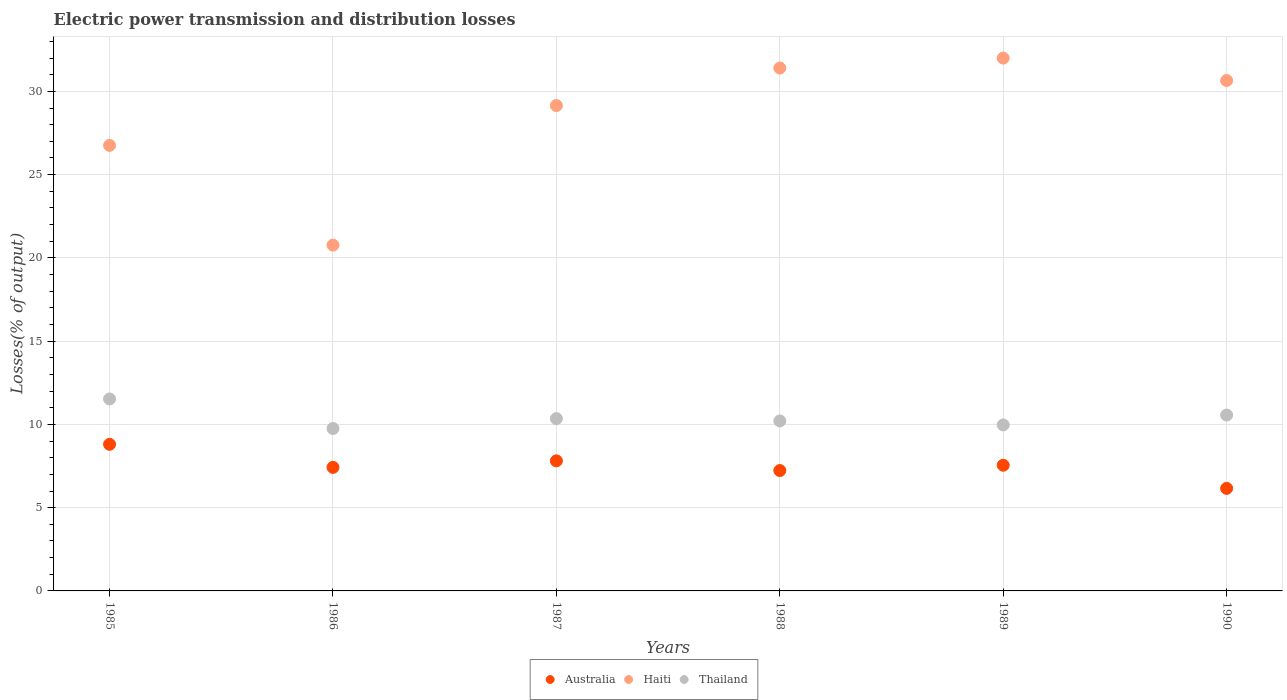How many different coloured dotlines are there?
Ensure brevity in your answer.  3. Is the number of dotlines equal to the number of legend labels?
Ensure brevity in your answer.  Yes. What is the electric power transmission and distribution losses in Thailand in 1988?
Provide a succinct answer. 10.21. Across all years, what is the maximum electric power transmission and distribution losses in Haiti?
Ensure brevity in your answer.  32. Across all years, what is the minimum electric power transmission and distribution losses in Thailand?
Your response must be concise. 9.75. In which year was the electric power transmission and distribution losses in Thailand maximum?
Your answer should be very brief. 1985. What is the total electric power transmission and distribution losses in Thailand in the graph?
Give a very brief answer. 62.37. What is the difference between the electric power transmission and distribution losses in Haiti in 1988 and that in 1990?
Your answer should be compact. 0.75. What is the difference between the electric power transmission and distribution losses in Haiti in 1986 and the electric power transmission and distribution losses in Australia in 1987?
Your answer should be very brief. 12.96. What is the average electric power transmission and distribution losses in Haiti per year?
Make the answer very short. 28.45. In the year 1986, what is the difference between the electric power transmission and distribution losses in Thailand and electric power transmission and distribution losses in Australia?
Offer a terse response. 2.33. In how many years, is the electric power transmission and distribution losses in Thailand greater than 9 %?
Ensure brevity in your answer.  6. What is the ratio of the electric power transmission and distribution losses in Thailand in 1987 to that in 1990?
Your response must be concise. 0.98. Is the electric power transmission and distribution losses in Australia in 1986 less than that in 1988?
Give a very brief answer. No. Is the difference between the electric power transmission and distribution losses in Thailand in 1986 and 1989 greater than the difference between the electric power transmission and distribution losses in Australia in 1986 and 1989?
Offer a terse response. No. What is the difference between the highest and the second highest electric power transmission and distribution losses in Australia?
Provide a succinct answer. 0.99. What is the difference between the highest and the lowest electric power transmission and distribution losses in Haiti?
Offer a terse response. 11.23. Are the values on the major ticks of Y-axis written in scientific E-notation?
Provide a short and direct response. No. Where does the legend appear in the graph?
Your response must be concise. Bottom center. What is the title of the graph?
Your response must be concise. Electric power transmission and distribution losses. What is the label or title of the Y-axis?
Ensure brevity in your answer.  Losses(% of output). What is the Losses(% of output) in Australia in 1985?
Offer a very short reply. 8.8. What is the Losses(% of output) in Haiti in 1985?
Provide a short and direct response. 26.76. What is the Losses(% of output) in Thailand in 1985?
Provide a succinct answer. 11.53. What is the Losses(% of output) in Australia in 1986?
Provide a succinct answer. 7.42. What is the Losses(% of output) of Haiti in 1986?
Offer a terse response. 20.77. What is the Losses(% of output) of Thailand in 1986?
Provide a short and direct response. 9.75. What is the Losses(% of output) of Australia in 1987?
Keep it short and to the point. 7.81. What is the Losses(% of output) in Haiti in 1987?
Provide a short and direct response. 29.15. What is the Losses(% of output) of Thailand in 1987?
Your answer should be compact. 10.35. What is the Losses(% of output) of Australia in 1988?
Make the answer very short. 7.23. What is the Losses(% of output) in Haiti in 1988?
Offer a very short reply. 31.4. What is the Losses(% of output) in Thailand in 1988?
Your answer should be compact. 10.21. What is the Losses(% of output) in Australia in 1989?
Make the answer very short. 7.55. What is the Losses(% of output) in Haiti in 1989?
Offer a very short reply. 32. What is the Losses(% of output) in Thailand in 1989?
Your response must be concise. 9.97. What is the Losses(% of output) in Australia in 1990?
Keep it short and to the point. 6.16. What is the Losses(% of output) in Haiti in 1990?
Provide a succinct answer. 30.65. What is the Losses(% of output) in Thailand in 1990?
Ensure brevity in your answer.  10.56. Across all years, what is the maximum Losses(% of output) in Australia?
Offer a very short reply. 8.8. Across all years, what is the maximum Losses(% of output) in Haiti?
Your response must be concise. 32. Across all years, what is the maximum Losses(% of output) in Thailand?
Provide a succinct answer. 11.53. Across all years, what is the minimum Losses(% of output) in Australia?
Offer a terse response. 6.16. Across all years, what is the minimum Losses(% of output) of Haiti?
Provide a succinct answer. 20.77. Across all years, what is the minimum Losses(% of output) of Thailand?
Give a very brief answer. 9.75. What is the total Losses(% of output) of Australia in the graph?
Provide a succinct answer. 44.97. What is the total Losses(% of output) of Haiti in the graph?
Your answer should be compact. 170.73. What is the total Losses(% of output) in Thailand in the graph?
Offer a terse response. 62.37. What is the difference between the Losses(% of output) in Australia in 1985 and that in 1986?
Your answer should be compact. 1.38. What is the difference between the Losses(% of output) of Haiti in 1985 and that in 1986?
Provide a short and direct response. 5.99. What is the difference between the Losses(% of output) in Thailand in 1985 and that in 1986?
Make the answer very short. 1.77. What is the difference between the Losses(% of output) in Haiti in 1985 and that in 1987?
Keep it short and to the point. -2.39. What is the difference between the Losses(% of output) of Thailand in 1985 and that in 1987?
Give a very brief answer. 1.18. What is the difference between the Losses(% of output) of Australia in 1985 and that in 1988?
Provide a short and direct response. 1.57. What is the difference between the Losses(% of output) of Haiti in 1985 and that in 1988?
Keep it short and to the point. -4.64. What is the difference between the Losses(% of output) of Thailand in 1985 and that in 1988?
Your response must be concise. 1.32. What is the difference between the Losses(% of output) of Australia in 1985 and that in 1989?
Ensure brevity in your answer.  1.26. What is the difference between the Losses(% of output) in Haiti in 1985 and that in 1989?
Offer a very short reply. -5.24. What is the difference between the Losses(% of output) in Thailand in 1985 and that in 1989?
Offer a very short reply. 1.56. What is the difference between the Losses(% of output) of Australia in 1985 and that in 1990?
Provide a short and direct response. 2.65. What is the difference between the Losses(% of output) of Haiti in 1985 and that in 1990?
Provide a succinct answer. -3.9. What is the difference between the Losses(% of output) of Thailand in 1985 and that in 1990?
Provide a succinct answer. 0.97. What is the difference between the Losses(% of output) of Australia in 1986 and that in 1987?
Your response must be concise. -0.39. What is the difference between the Losses(% of output) of Haiti in 1986 and that in 1987?
Provide a short and direct response. -8.38. What is the difference between the Losses(% of output) of Thailand in 1986 and that in 1987?
Give a very brief answer. -0.59. What is the difference between the Losses(% of output) of Australia in 1986 and that in 1988?
Offer a very short reply. 0.19. What is the difference between the Losses(% of output) of Haiti in 1986 and that in 1988?
Ensure brevity in your answer.  -10.63. What is the difference between the Losses(% of output) of Thailand in 1986 and that in 1988?
Offer a very short reply. -0.45. What is the difference between the Losses(% of output) in Australia in 1986 and that in 1989?
Keep it short and to the point. -0.13. What is the difference between the Losses(% of output) in Haiti in 1986 and that in 1989?
Your response must be concise. -11.23. What is the difference between the Losses(% of output) of Thailand in 1986 and that in 1989?
Provide a short and direct response. -0.21. What is the difference between the Losses(% of output) in Australia in 1986 and that in 1990?
Keep it short and to the point. 1.26. What is the difference between the Losses(% of output) of Haiti in 1986 and that in 1990?
Offer a terse response. -9.89. What is the difference between the Losses(% of output) of Thailand in 1986 and that in 1990?
Offer a terse response. -0.81. What is the difference between the Losses(% of output) in Australia in 1987 and that in 1988?
Make the answer very short. 0.58. What is the difference between the Losses(% of output) of Haiti in 1987 and that in 1988?
Give a very brief answer. -2.25. What is the difference between the Losses(% of output) of Thailand in 1987 and that in 1988?
Your answer should be very brief. 0.14. What is the difference between the Losses(% of output) in Australia in 1987 and that in 1989?
Your answer should be compact. 0.26. What is the difference between the Losses(% of output) of Haiti in 1987 and that in 1989?
Give a very brief answer. -2.85. What is the difference between the Losses(% of output) of Thailand in 1987 and that in 1989?
Give a very brief answer. 0.38. What is the difference between the Losses(% of output) of Australia in 1987 and that in 1990?
Your answer should be very brief. 1.65. What is the difference between the Losses(% of output) of Haiti in 1987 and that in 1990?
Your answer should be compact. -1.5. What is the difference between the Losses(% of output) in Thailand in 1987 and that in 1990?
Provide a short and direct response. -0.21. What is the difference between the Losses(% of output) in Australia in 1988 and that in 1989?
Your response must be concise. -0.32. What is the difference between the Losses(% of output) of Haiti in 1988 and that in 1989?
Keep it short and to the point. -0.6. What is the difference between the Losses(% of output) in Thailand in 1988 and that in 1989?
Make the answer very short. 0.24. What is the difference between the Losses(% of output) of Australia in 1988 and that in 1990?
Your answer should be very brief. 1.07. What is the difference between the Losses(% of output) of Haiti in 1988 and that in 1990?
Make the answer very short. 0.75. What is the difference between the Losses(% of output) in Thailand in 1988 and that in 1990?
Provide a short and direct response. -0.35. What is the difference between the Losses(% of output) of Australia in 1989 and that in 1990?
Your answer should be very brief. 1.39. What is the difference between the Losses(% of output) of Haiti in 1989 and that in 1990?
Your answer should be compact. 1.35. What is the difference between the Losses(% of output) of Thailand in 1989 and that in 1990?
Provide a succinct answer. -0.59. What is the difference between the Losses(% of output) of Australia in 1985 and the Losses(% of output) of Haiti in 1986?
Ensure brevity in your answer.  -11.96. What is the difference between the Losses(% of output) in Australia in 1985 and the Losses(% of output) in Thailand in 1986?
Offer a terse response. -0.95. What is the difference between the Losses(% of output) in Haiti in 1985 and the Losses(% of output) in Thailand in 1986?
Offer a very short reply. 17. What is the difference between the Losses(% of output) in Australia in 1985 and the Losses(% of output) in Haiti in 1987?
Offer a very short reply. -20.34. What is the difference between the Losses(% of output) in Australia in 1985 and the Losses(% of output) in Thailand in 1987?
Make the answer very short. -1.54. What is the difference between the Losses(% of output) of Haiti in 1985 and the Losses(% of output) of Thailand in 1987?
Offer a very short reply. 16.41. What is the difference between the Losses(% of output) in Australia in 1985 and the Losses(% of output) in Haiti in 1988?
Offer a terse response. -22.6. What is the difference between the Losses(% of output) of Australia in 1985 and the Losses(% of output) of Thailand in 1988?
Keep it short and to the point. -1.4. What is the difference between the Losses(% of output) of Haiti in 1985 and the Losses(% of output) of Thailand in 1988?
Provide a short and direct response. 16.55. What is the difference between the Losses(% of output) of Australia in 1985 and the Losses(% of output) of Haiti in 1989?
Make the answer very short. -23.2. What is the difference between the Losses(% of output) in Australia in 1985 and the Losses(% of output) in Thailand in 1989?
Provide a succinct answer. -1.16. What is the difference between the Losses(% of output) in Haiti in 1985 and the Losses(% of output) in Thailand in 1989?
Offer a very short reply. 16.79. What is the difference between the Losses(% of output) in Australia in 1985 and the Losses(% of output) in Haiti in 1990?
Your response must be concise. -21.85. What is the difference between the Losses(% of output) of Australia in 1985 and the Losses(% of output) of Thailand in 1990?
Offer a very short reply. -1.76. What is the difference between the Losses(% of output) of Haiti in 1985 and the Losses(% of output) of Thailand in 1990?
Keep it short and to the point. 16.2. What is the difference between the Losses(% of output) in Australia in 1986 and the Losses(% of output) in Haiti in 1987?
Provide a short and direct response. -21.73. What is the difference between the Losses(% of output) in Australia in 1986 and the Losses(% of output) in Thailand in 1987?
Offer a terse response. -2.93. What is the difference between the Losses(% of output) in Haiti in 1986 and the Losses(% of output) in Thailand in 1987?
Give a very brief answer. 10.42. What is the difference between the Losses(% of output) in Australia in 1986 and the Losses(% of output) in Haiti in 1988?
Provide a short and direct response. -23.98. What is the difference between the Losses(% of output) of Australia in 1986 and the Losses(% of output) of Thailand in 1988?
Provide a succinct answer. -2.79. What is the difference between the Losses(% of output) in Haiti in 1986 and the Losses(% of output) in Thailand in 1988?
Offer a terse response. 10.56. What is the difference between the Losses(% of output) in Australia in 1986 and the Losses(% of output) in Haiti in 1989?
Keep it short and to the point. -24.58. What is the difference between the Losses(% of output) of Australia in 1986 and the Losses(% of output) of Thailand in 1989?
Give a very brief answer. -2.55. What is the difference between the Losses(% of output) in Haiti in 1986 and the Losses(% of output) in Thailand in 1989?
Keep it short and to the point. 10.8. What is the difference between the Losses(% of output) in Australia in 1986 and the Losses(% of output) in Haiti in 1990?
Offer a terse response. -23.23. What is the difference between the Losses(% of output) of Australia in 1986 and the Losses(% of output) of Thailand in 1990?
Make the answer very short. -3.14. What is the difference between the Losses(% of output) of Haiti in 1986 and the Losses(% of output) of Thailand in 1990?
Your answer should be very brief. 10.21. What is the difference between the Losses(% of output) of Australia in 1987 and the Losses(% of output) of Haiti in 1988?
Ensure brevity in your answer.  -23.59. What is the difference between the Losses(% of output) of Australia in 1987 and the Losses(% of output) of Thailand in 1988?
Provide a succinct answer. -2.4. What is the difference between the Losses(% of output) in Haiti in 1987 and the Losses(% of output) in Thailand in 1988?
Make the answer very short. 18.94. What is the difference between the Losses(% of output) of Australia in 1987 and the Losses(% of output) of Haiti in 1989?
Provide a succinct answer. -24.19. What is the difference between the Losses(% of output) in Australia in 1987 and the Losses(% of output) in Thailand in 1989?
Ensure brevity in your answer.  -2.16. What is the difference between the Losses(% of output) in Haiti in 1987 and the Losses(% of output) in Thailand in 1989?
Offer a very short reply. 19.18. What is the difference between the Losses(% of output) of Australia in 1987 and the Losses(% of output) of Haiti in 1990?
Your answer should be compact. -22.84. What is the difference between the Losses(% of output) of Australia in 1987 and the Losses(% of output) of Thailand in 1990?
Your answer should be compact. -2.75. What is the difference between the Losses(% of output) of Haiti in 1987 and the Losses(% of output) of Thailand in 1990?
Your answer should be compact. 18.59. What is the difference between the Losses(% of output) in Australia in 1988 and the Losses(% of output) in Haiti in 1989?
Offer a terse response. -24.77. What is the difference between the Losses(% of output) in Australia in 1988 and the Losses(% of output) in Thailand in 1989?
Give a very brief answer. -2.74. What is the difference between the Losses(% of output) in Haiti in 1988 and the Losses(% of output) in Thailand in 1989?
Your answer should be compact. 21.43. What is the difference between the Losses(% of output) of Australia in 1988 and the Losses(% of output) of Haiti in 1990?
Your response must be concise. -23.42. What is the difference between the Losses(% of output) in Australia in 1988 and the Losses(% of output) in Thailand in 1990?
Give a very brief answer. -3.33. What is the difference between the Losses(% of output) of Haiti in 1988 and the Losses(% of output) of Thailand in 1990?
Make the answer very short. 20.84. What is the difference between the Losses(% of output) of Australia in 1989 and the Losses(% of output) of Haiti in 1990?
Make the answer very short. -23.11. What is the difference between the Losses(% of output) of Australia in 1989 and the Losses(% of output) of Thailand in 1990?
Offer a very short reply. -3.01. What is the difference between the Losses(% of output) of Haiti in 1989 and the Losses(% of output) of Thailand in 1990?
Your answer should be compact. 21.44. What is the average Losses(% of output) in Australia per year?
Offer a terse response. 7.5. What is the average Losses(% of output) in Haiti per year?
Keep it short and to the point. 28.45. What is the average Losses(% of output) of Thailand per year?
Keep it short and to the point. 10.4. In the year 1985, what is the difference between the Losses(% of output) in Australia and Losses(% of output) in Haiti?
Provide a succinct answer. -17.95. In the year 1985, what is the difference between the Losses(% of output) in Australia and Losses(% of output) in Thailand?
Provide a succinct answer. -2.72. In the year 1985, what is the difference between the Losses(% of output) of Haiti and Losses(% of output) of Thailand?
Keep it short and to the point. 15.23. In the year 1986, what is the difference between the Losses(% of output) of Australia and Losses(% of output) of Haiti?
Your response must be concise. -13.35. In the year 1986, what is the difference between the Losses(% of output) of Australia and Losses(% of output) of Thailand?
Provide a short and direct response. -2.33. In the year 1986, what is the difference between the Losses(% of output) of Haiti and Losses(% of output) of Thailand?
Your answer should be very brief. 11.01. In the year 1987, what is the difference between the Losses(% of output) in Australia and Losses(% of output) in Haiti?
Offer a very short reply. -21.34. In the year 1987, what is the difference between the Losses(% of output) in Australia and Losses(% of output) in Thailand?
Provide a succinct answer. -2.54. In the year 1987, what is the difference between the Losses(% of output) in Haiti and Losses(% of output) in Thailand?
Ensure brevity in your answer.  18.8. In the year 1988, what is the difference between the Losses(% of output) of Australia and Losses(% of output) of Haiti?
Your response must be concise. -24.17. In the year 1988, what is the difference between the Losses(% of output) in Australia and Losses(% of output) in Thailand?
Your answer should be very brief. -2.98. In the year 1988, what is the difference between the Losses(% of output) of Haiti and Losses(% of output) of Thailand?
Your answer should be very brief. 21.19. In the year 1989, what is the difference between the Losses(% of output) in Australia and Losses(% of output) in Haiti?
Make the answer very short. -24.45. In the year 1989, what is the difference between the Losses(% of output) of Australia and Losses(% of output) of Thailand?
Offer a terse response. -2.42. In the year 1989, what is the difference between the Losses(% of output) of Haiti and Losses(% of output) of Thailand?
Your answer should be very brief. 22.03. In the year 1990, what is the difference between the Losses(% of output) of Australia and Losses(% of output) of Haiti?
Your answer should be very brief. -24.5. In the year 1990, what is the difference between the Losses(% of output) of Australia and Losses(% of output) of Thailand?
Give a very brief answer. -4.4. In the year 1990, what is the difference between the Losses(% of output) in Haiti and Losses(% of output) in Thailand?
Make the answer very short. 20.09. What is the ratio of the Losses(% of output) in Australia in 1985 to that in 1986?
Your answer should be compact. 1.19. What is the ratio of the Losses(% of output) in Haiti in 1985 to that in 1986?
Offer a terse response. 1.29. What is the ratio of the Losses(% of output) of Thailand in 1985 to that in 1986?
Offer a terse response. 1.18. What is the ratio of the Losses(% of output) in Australia in 1985 to that in 1987?
Offer a very short reply. 1.13. What is the ratio of the Losses(% of output) in Haiti in 1985 to that in 1987?
Give a very brief answer. 0.92. What is the ratio of the Losses(% of output) in Thailand in 1985 to that in 1987?
Offer a very short reply. 1.11. What is the ratio of the Losses(% of output) of Australia in 1985 to that in 1988?
Provide a short and direct response. 1.22. What is the ratio of the Losses(% of output) in Haiti in 1985 to that in 1988?
Ensure brevity in your answer.  0.85. What is the ratio of the Losses(% of output) of Thailand in 1985 to that in 1988?
Keep it short and to the point. 1.13. What is the ratio of the Losses(% of output) in Australia in 1985 to that in 1989?
Provide a succinct answer. 1.17. What is the ratio of the Losses(% of output) of Haiti in 1985 to that in 1989?
Ensure brevity in your answer.  0.84. What is the ratio of the Losses(% of output) of Thailand in 1985 to that in 1989?
Make the answer very short. 1.16. What is the ratio of the Losses(% of output) in Australia in 1985 to that in 1990?
Give a very brief answer. 1.43. What is the ratio of the Losses(% of output) of Haiti in 1985 to that in 1990?
Offer a terse response. 0.87. What is the ratio of the Losses(% of output) of Thailand in 1985 to that in 1990?
Provide a succinct answer. 1.09. What is the ratio of the Losses(% of output) of Australia in 1986 to that in 1987?
Your answer should be compact. 0.95. What is the ratio of the Losses(% of output) of Haiti in 1986 to that in 1987?
Provide a short and direct response. 0.71. What is the ratio of the Losses(% of output) in Thailand in 1986 to that in 1987?
Your response must be concise. 0.94. What is the ratio of the Losses(% of output) in Australia in 1986 to that in 1988?
Your answer should be compact. 1.03. What is the ratio of the Losses(% of output) in Haiti in 1986 to that in 1988?
Offer a very short reply. 0.66. What is the ratio of the Losses(% of output) in Thailand in 1986 to that in 1988?
Your answer should be compact. 0.96. What is the ratio of the Losses(% of output) in Haiti in 1986 to that in 1989?
Provide a short and direct response. 0.65. What is the ratio of the Losses(% of output) in Thailand in 1986 to that in 1989?
Your answer should be compact. 0.98. What is the ratio of the Losses(% of output) in Australia in 1986 to that in 1990?
Offer a very short reply. 1.21. What is the ratio of the Losses(% of output) in Haiti in 1986 to that in 1990?
Provide a succinct answer. 0.68. What is the ratio of the Losses(% of output) of Thailand in 1986 to that in 1990?
Your answer should be very brief. 0.92. What is the ratio of the Losses(% of output) of Australia in 1987 to that in 1988?
Your answer should be very brief. 1.08. What is the ratio of the Losses(% of output) of Haiti in 1987 to that in 1988?
Your answer should be very brief. 0.93. What is the ratio of the Losses(% of output) of Thailand in 1987 to that in 1988?
Give a very brief answer. 1.01. What is the ratio of the Losses(% of output) in Australia in 1987 to that in 1989?
Provide a succinct answer. 1.03. What is the ratio of the Losses(% of output) of Haiti in 1987 to that in 1989?
Your response must be concise. 0.91. What is the ratio of the Losses(% of output) of Thailand in 1987 to that in 1989?
Provide a short and direct response. 1.04. What is the ratio of the Losses(% of output) in Australia in 1987 to that in 1990?
Provide a succinct answer. 1.27. What is the ratio of the Losses(% of output) of Haiti in 1987 to that in 1990?
Give a very brief answer. 0.95. What is the ratio of the Losses(% of output) of Thailand in 1987 to that in 1990?
Give a very brief answer. 0.98. What is the ratio of the Losses(% of output) in Australia in 1988 to that in 1989?
Make the answer very short. 0.96. What is the ratio of the Losses(% of output) of Haiti in 1988 to that in 1989?
Offer a terse response. 0.98. What is the ratio of the Losses(% of output) of Australia in 1988 to that in 1990?
Provide a short and direct response. 1.17. What is the ratio of the Losses(% of output) in Haiti in 1988 to that in 1990?
Keep it short and to the point. 1.02. What is the ratio of the Losses(% of output) in Thailand in 1988 to that in 1990?
Your answer should be very brief. 0.97. What is the ratio of the Losses(% of output) of Australia in 1989 to that in 1990?
Provide a succinct answer. 1.23. What is the ratio of the Losses(% of output) in Haiti in 1989 to that in 1990?
Ensure brevity in your answer.  1.04. What is the ratio of the Losses(% of output) in Thailand in 1989 to that in 1990?
Give a very brief answer. 0.94. What is the difference between the highest and the second highest Losses(% of output) of Haiti?
Provide a succinct answer. 0.6. What is the difference between the highest and the second highest Losses(% of output) of Thailand?
Offer a very short reply. 0.97. What is the difference between the highest and the lowest Losses(% of output) of Australia?
Your answer should be compact. 2.65. What is the difference between the highest and the lowest Losses(% of output) in Haiti?
Your answer should be compact. 11.23. What is the difference between the highest and the lowest Losses(% of output) of Thailand?
Ensure brevity in your answer.  1.77. 